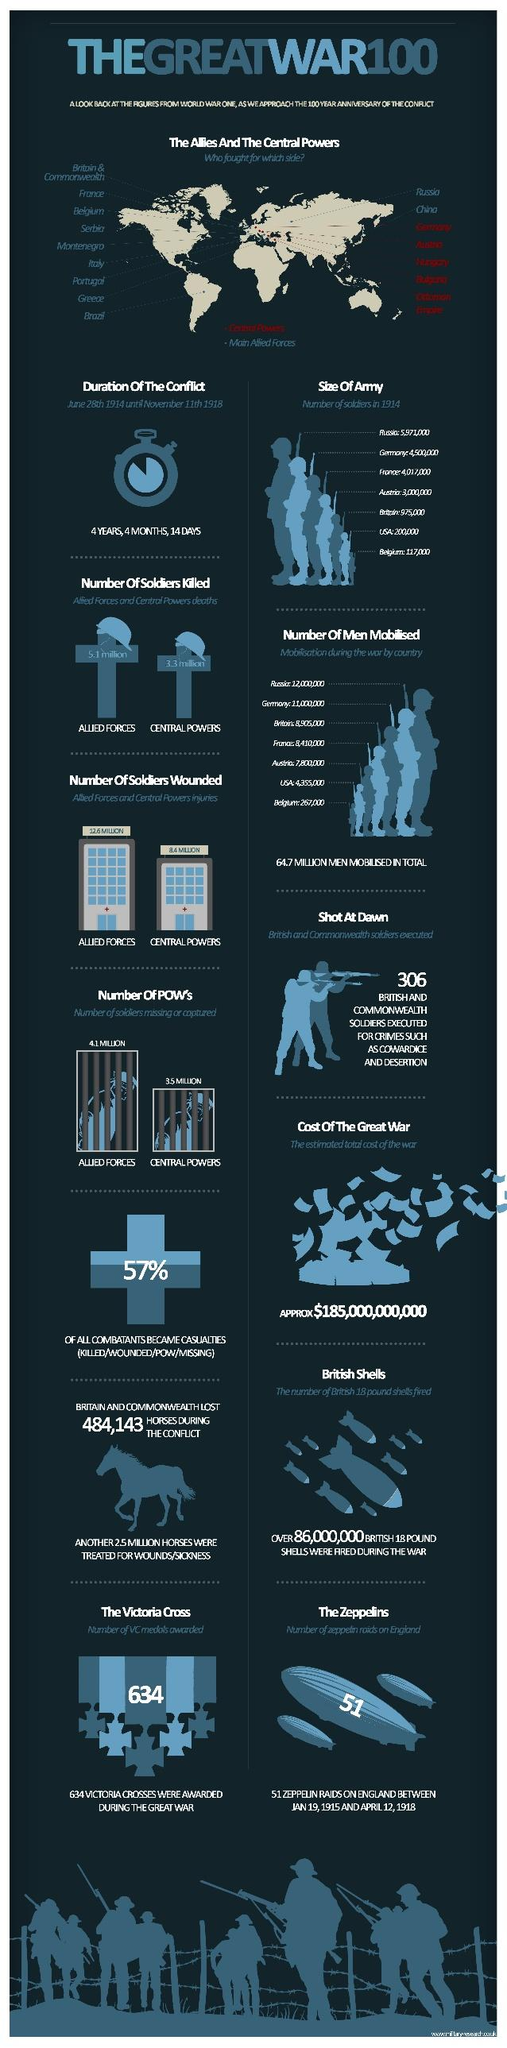Point out several critical features in this image. The Allies were engaged in a war against the Central powers. Approximately 4,355,000 men were mobilized in the United States during the war. Germany had more soldiers than France, Belgium, and any other country in the world. The duration of the conflict was approximately 4 years, 4 months, and 14 days. Out of the total of 306 soldiers who were executed by firing squad, how many were shot at dawn? 